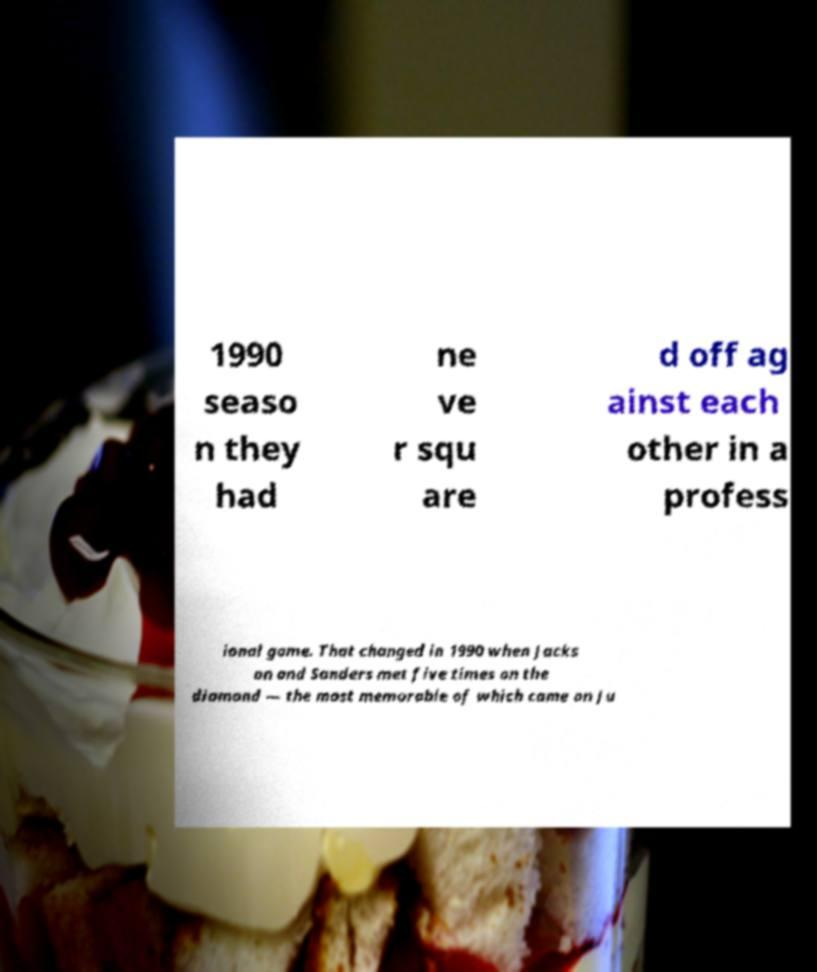Can you accurately transcribe the text from the provided image for me? 1990 seaso n they had ne ve r squ are d off ag ainst each other in a profess ional game. That changed in 1990 when Jacks on and Sanders met five times on the diamond — the most memorable of which came on Ju 